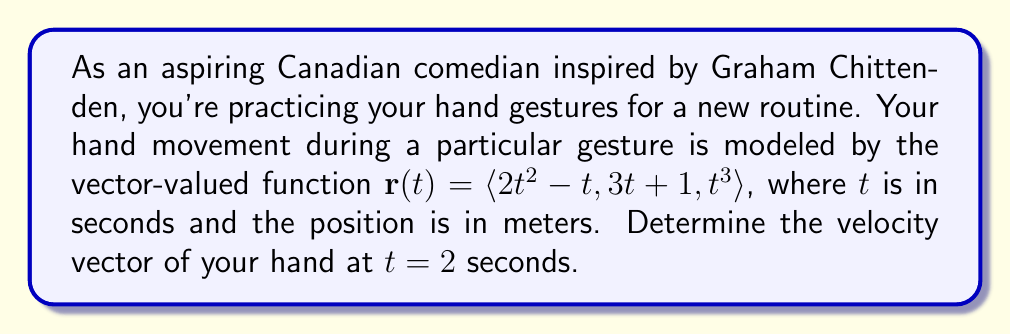Provide a solution to this math problem. To find the velocity vector, we need to differentiate the position vector $\mathbf{r}(t)$ with respect to time.

The velocity vector is given by $\mathbf{v}(t) = \frac{d\mathbf{r}}{dt}$.

Let's differentiate each component of $\mathbf{r}(t)$:

1. For $x(t) = 2t^2 - t$:
   $\frac{dx}{dt} = 4t - 1$

2. For $y(t) = 3t + 1$:
   $\frac{dy}{dt} = 3$

3. For $z(t) = t^3$:
   $\frac{dz}{dt} = 3t^2$

Therefore, the velocity vector is:
$\mathbf{v}(t) = \langle 4t - 1, 3, 3t^2 \rangle$

To find the velocity at $t = 2$ seconds, we substitute $t = 2$ into this expression:

$\mathbf{v}(2) = \langle 4(2) - 1, 3, 3(2)^2 \rangle$
$= \langle 8 - 1, 3, 3(4) \rangle$
$= \langle 7, 3, 12 \rangle$

This gives us the velocity vector at $t = 2$ seconds.
Answer: The velocity vector of the comedian's hand at $t = 2$ seconds is $\mathbf{v}(2) = \langle 7, 3, 12 \rangle$ meters per second. 